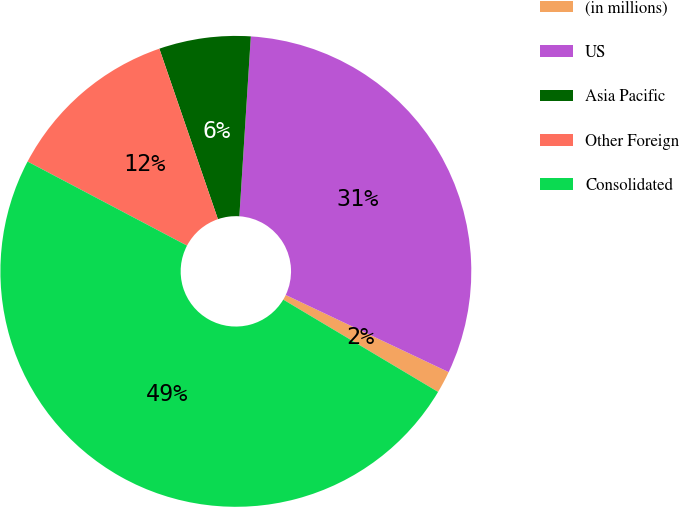Convert chart to OTSL. <chart><loc_0><loc_0><loc_500><loc_500><pie_chart><fcel>(in millions)<fcel>US<fcel>Asia Pacific<fcel>Other Foreign<fcel>Consolidated<nl><fcel>1.52%<fcel>31.02%<fcel>6.28%<fcel>12.01%<fcel>49.16%<nl></chart> 